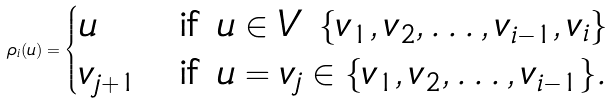Convert formula to latex. <formula><loc_0><loc_0><loc_500><loc_500>\rho _ { i } ( u ) = \begin{cases} u & \text {if } u \in V \ \{ v _ { 1 } , v _ { 2 } , \dots , v _ { i - 1 } , v _ { i } \} \\ v _ { j + 1 } & \text {if } u = v _ { j } \in \{ v _ { 1 } , v _ { 2 } , \dots , v _ { i - 1 } \} . \end{cases}</formula> 